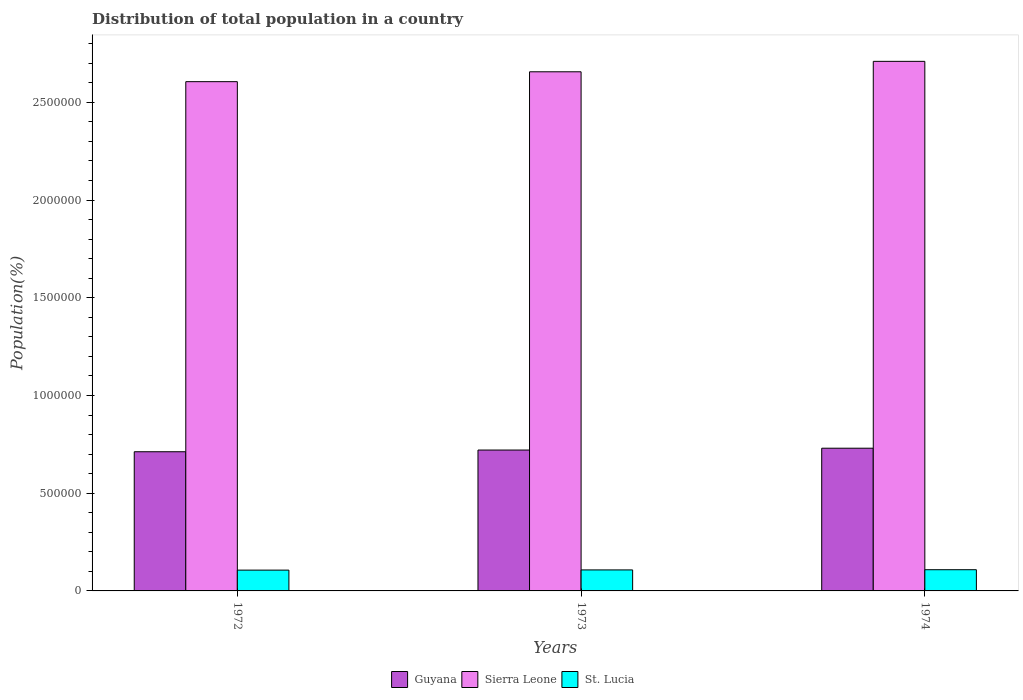Are the number of bars per tick equal to the number of legend labels?
Make the answer very short. Yes. How many bars are there on the 1st tick from the right?
Offer a very short reply. 3. What is the label of the 1st group of bars from the left?
Give a very brief answer. 1972. What is the population of in St. Lucia in 1974?
Your response must be concise. 1.09e+05. Across all years, what is the maximum population of in St. Lucia?
Provide a succinct answer. 1.09e+05. Across all years, what is the minimum population of in Guyana?
Make the answer very short. 7.12e+05. In which year was the population of in St. Lucia maximum?
Offer a very short reply. 1974. What is the total population of in Guyana in the graph?
Your response must be concise. 2.16e+06. What is the difference between the population of in St. Lucia in 1972 and that in 1973?
Offer a terse response. -1003. What is the difference between the population of in Sierra Leone in 1973 and the population of in St. Lucia in 1972?
Provide a short and direct response. 2.55e+06. What is the average population of in Sierra Leone per year?
Ensure brevity in your answer.  2.66e+06. In the year 1974, what is the difference between the population of in St. Lucia and population of in Guyana?
Ensure brevity in your answer.  -6.22e+05. In how many years, is the population of in St. Lucia greater than 2100000 %?
Keep it short and to the point. 0. What is the ratio of the population of in Sierra Leone in 1973 to that in 1974?
Give a very brief answer. 0.98. Is the population of in St. Lucia in 1973 less than that in 1974?
Ensure brevity in your answer.  Yes. Is the difference between the population of in St. Lucia in 1972 and 1973 greater than the difference between the population of in Guyana in 1972 and 1973?
Keep it short and to the point. Yes. What is the difference between the highest and the second highest population of in Guyana?
Ensure brevity in your answer.  9308. What is the difference between the highest and the lowest population of in St. Lucia?
Provide a succinct answer. 2076. Is the sum of the population of in St. Lucia in 1972 and 1973 greater than the maximum population of in Sierra Leone across all years?
Your answer should be compact. No. What does the 3rd bar from the left in 1973 represents?
Make the answer very short. St. Lucia. What does the 3rd bar from the right in 1974 represents?
Your answer should be very brief. Guyana. Is it the case that in every year, the sum of the population of in St. Lucia and population of in Guyana is greater than the population of in Sierra Leone?
Keep it short and to the point. No. How many bars are there?
Offer a very short reply. 9. Are all the bars in the graph horizontal?
Ensure brevity in your answer.  No. Does the graph contain grids?
Make the answer very short. No. Where does the legend appear in the graph?
Your answer should be very brief. Bottom center. How are the legend labels stacked?
Provide a succinct answer. Horizontal. What is the title of the graph?
Make the answer very short. Distribution of total population in a country. What is the label or title of the Y-axis?
Make the answer very short. Population(%). What is the Population(%) of Guyana in 1972?
Your answer should be very brief. 7.12e+05. What is the Population(%) of Sierra Leone in 1972?
Offer a terse response. 2.61e+06. What is the Population(%) in St. Lucia in 1972?
Provide a succinct answer. 1.06e+05. What is the Population(%) in Guyana in 1973?
Provide a succinct answer. 7.21e+05. What is the Population(%) of Sierra Leone in 1973?
Provide a short and direct response. 2.66e+06. What is the Population(%) in St. Lucia in 1973?
Offer a very short reply. 1.07e+05. What is the Population(%) of Guyana in 1974?
Keep it short and to the point. 7.30e+05. What is the Population(%) of Sierra Leone in 1974?
Your answer should be very brief. 2.71e+06. What is the Population(%) of St. Lucia in 1974?
Keep it short and to the point. 1.09e+05. Across all years, what is the maximum Population(%) of Guyana?
Your response must be concise. 7.30e+05. Across all years, what is the maximum Population(%) in Sierra Leone?
Provide a short and direct response. 2.71e+06. Across all years, what is the maximum Population(%) of St. Lucia?
Offer a very short reply. 1.09e+05. Across all years, what is the minimum Population(%) in Guyana?
Your answer should be compact. 7.12e+05. Across all years, what is the minimum Population(%) of Sierra Leone?
Keep it short and to the point. 2.61e+06. Across all years, what is the minimum Population(%) of St. Lucia?
Provide a short and direct response. 1.06e+05. What is the total Population(%) of Guyana in the graph?
Keep it short and to the point. 2.16e+06. What is the total Population(%) of Sierra Leone in the graph?
Give a very brief answer. 7.97e+06. What is the total Population(%) in St. Lucia in the graph?
Offer a very short reply. 3.22e+05. What is the difference between the Population(%) of Guyana in 1972 and that in 1973?
Make the answer very short. -8731. What is the difference between the Population(%) in Sierra Leone in 1972 and that in 1973?
Keep it short and to the point. -5.05e+04. What is the difference between the Population(%) of St. Lucia in 1972 and that in 1973?
Provide a succinct answer. -1003. What is the difference between the Population(%) in Guyana in 1972 and that in 1974?
Your response must be concise. -1.80e+04. What is the difference between the Population(%) in Sierra Leone in 1972 and that in 1974?
Offer a very short reply. -1.04e+05. What is the difference between the Population(%) of St. Lucia in 1972 and that in 1974?
Ensure brevity in your answer.  -2076. What is the difference between the Population(%) in Guyana in 1973 and that in 1974?
Provide a short and direct response. -9308. What is the difference between the Population(%) in Sierra Leone in 1973 and that in 1974?
Your answer should be very brief. -5.34e+04. What is the difference between the Population(%) in St. Lucia in 1973 and that in 1974?
Give a very brief answer. -1073. What is the difference between the Population(%) of Guyana in 1972 and the Population(%) of Sierra Leone in 1973?
Give a very brief answer. -1.94e+06. What is the difference between the Population(%) in Guyana in 1972 and the Population(%) in St. Lucia in 1973?
Ensure brevity in your answer.  6.05e+05. What is the difference between the Population(%) of Sierra Leone in 1972 and the Population(%) of St. Lucia in 1973?
Your answer should be very brief. 2.50e+06. What is the difference between the Population(%) of Guyana in 1972 and the Population(%) of Sierra Leone in 1974?
Your answer should be very brief. -2.00e+06. What is the difference between the Population(%) in Guyana in 1972 and the Population(%) in St. Lucia in 1974?
Ensure brevity in your answer.  6.04e+05. What is the difference between the Population(%) in Sierra Leone in 1972 and the Population(%) in St. Lucia in 1974?
Offer a very short reply. 2.50e+06. What is the difference between the Population(%) in Guyana in 1973 and the Population(%) in Sierra Leone in 1974?
Give a very brief answer. -1.99e+06. What is the difference between the Population(%) in Guyana in 1973 and the Population(%) in St. Lucia in 1974?
Provide a succinct answer. 6.12e+05. What is the difference between the Population(%) in Sierra Leone in 1973 and the Population(%) in St. Lucia in 1974?
Keep it short and to the point. 2.55e+06. What is the average Population(%) of Guyana per year?
Offer a very short reply. 7.21e+05. What is the average Population(%) in Sierra Leone per year?
Ensure brevity in your answer.  2.66e+06. What is the average Population(%) of St. Lucia per year?
Provide a short and direct response. 1.07e+05. In the year 1972, what is the difference between the Population(%) in Guyana and Population(%) in Sierra Leone?
Give a very brief answer. -1.89e+06. In the year 1972, what is the difference between the Population(%) of Guyana and Population(%) of St. Lucia?
Your response must be concise. 6.06e+05. In the year 1972, what is the difference between the Population(%) in Sierra Leone and Population(%) in St. Lucia?
Make the answer very short. 2.50e+06. In the year 1973, what is the difference between the Population(%) in Guyana and Population(%) in Sierra Leone?
Provide a short and direct response. -1.94e+06. In the year 1973, what is the difference between the Population(%) of Guyana and Population(%) of St. Lucia?
Provide a succinct answer. 6.13e+05. In the year 1973, what is the difference between the Population(%) of Sierra Leone and Population(%) of St. Lucia?
Offer a very short reply. 2.55e+06. In the year 1974, what is the difference between the Population(%) of Guyana and Population(%) of Sierra Leone?
Provide a succinct answer. -1.98e+06. In the year 1974, what is the difference between the Population(%) of Guyana and Population(%) of St. Lucia?
Your answer should be compact. 6.22e+05. In the year 1974, what is the difference between the Population(%) in Sierra Leone and Population(%) in St. Lucia?
Your response must be concise. 2.60e+06. What is the ratio of the Population(%) of Guyana in 1972 to that in 1973?
Give a very brief answer. 0.99. What is the ratio of the Population(%) of St. Lucia in 1972 to that in 1973?
Your answer should be very brief. 0.99. What is the ratio of the Population(%) in Guyana in 1972 to that in 1974?
Provide a succinct answer. 0.98. What is the ratio of the Population(%) in Sierra Leone in 1972 to that in 1974?
Ensure brevity in your answer.  0.96. What is the ratio of the Population(%) in St. Lucia in 1972 to that in 1974?
Your answer should be very brief. 0.98. What is the ratio of the Population(%) of Guyana in 1973 to that in 1974?
Keep it short and to the point. 0.99. What is the ratio of the Population(%) in Sierra Leone in 1973 to that in 1974?
Make the answer very short. 0.98. What is the difference between the highest and the second highest Population(%) in Guyana?
Keep it short and to the point. 9308. What is the difference between the highest and the second highest Population(%) of Sierra Leone?
Offer a very short reply. 5.34e+04. What is the difference between the highest and the second highest Population(%) of St. Lucia?
Make the answer very short. 1073. What is the difference between the highest and the lowest Population(%) in Guyana?
Offer a very short reply. 1.80e+04. What is the difference between the highest and the lowest Population(%) of Sierra Leone?
Your response must be concise. 1.04e+05. What is the difference between the highest and the lowest Population(%) in St. Lucia?
Your answer should be compact. 2076. 